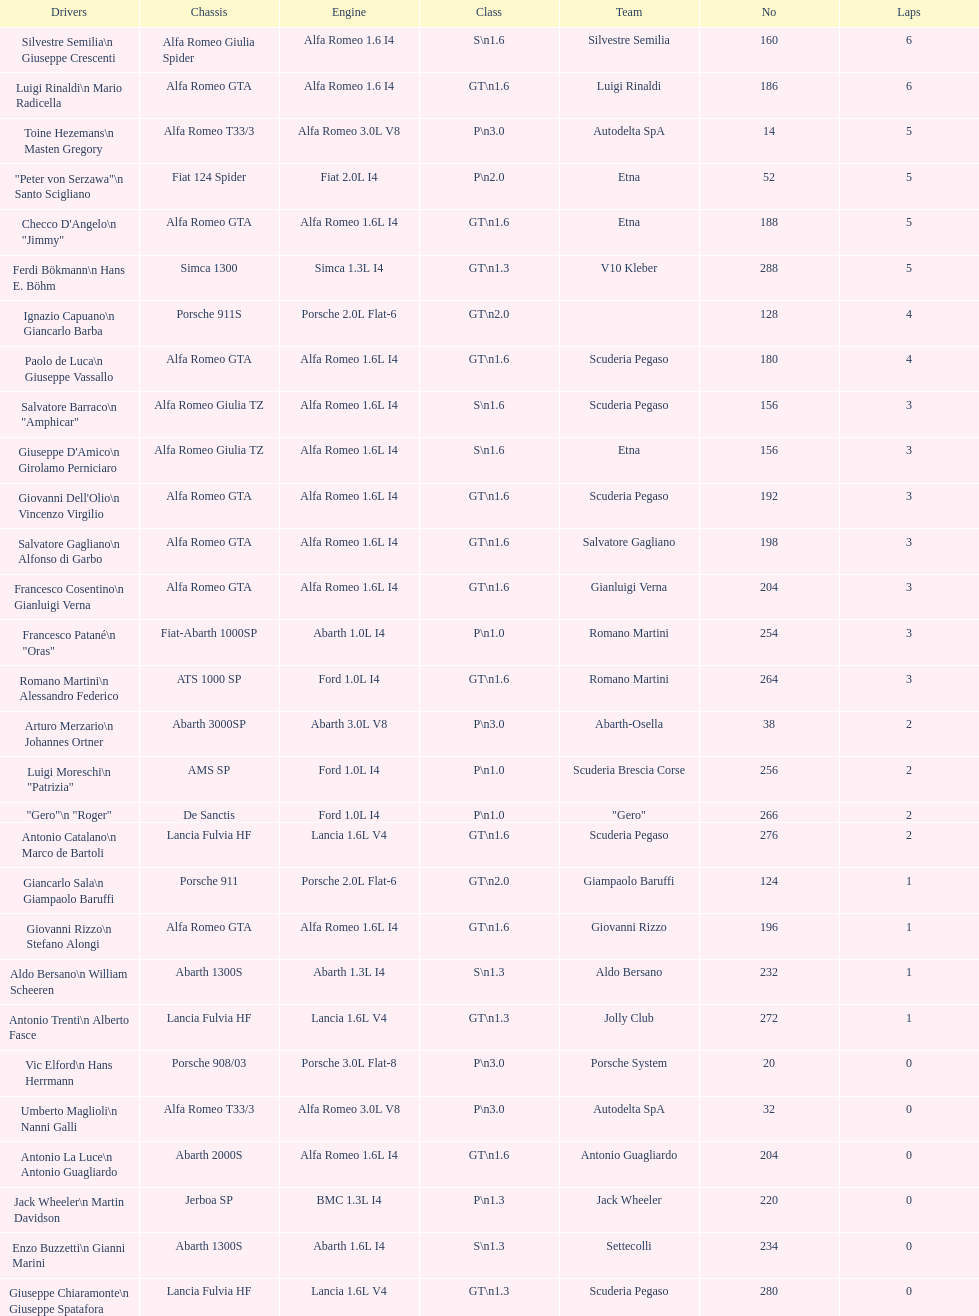How many drivers are from italy? 48. Would you be able to parse every entry in this table? {'header': ['Drivers', 'Chassis', 'Engine', 'Class', 'Team', 'No', 'Laps'], 'rows': [['Silvestre Semilia\\n Giuseppe Crescenti', 'Alfa Romeo Giulia Spider', 'Alfa Romeo 1.6 I4', 'S\\n1.6', 'Silvestre Semilia', '160', '6'], ['Luigi Rinaldi\\n Mario Radicella', 'Alfa Romeo GTA', 'Alfa Romeo 1.6 I4', 'GT\\n1.6', 'Luigi Rinaldi', '186', '6'], ['Toine Hezemans\\n Masten Gregory', 'Alfa Romeo T33/3', 'Alfa Romeo 3.0L V8', 'P\\n3.0', 'Autodelta SpA', '14', '5'], ['"Peter von Serzawa"\\n Santo Scigliano', 'Fiat 124 Spider', 'Fiat 2.0L I4', 'P\\n2.0', 'Etna', '52', '5'], ['Checco D\'Angelo\\n "Jimmy"', 'Alfa Romeo GTA', 'Alfa Romeo 1.6L I4', 'GT\\n1.6', 'Etna', '188', '5'], ['Ferdi Bökmann\\n Hans E. Böhm', 'Simca 1300', 'Simca 1.3L I4', 'GT\\n1.3', 'V10 Kleber', '288', '5'], ['Ignazio Capuano\\n Giancarlo Barba', 'Porsche 911S', 'Porsche 2.0L Flat-6', 'GT\\n2.0', '', '128', '4'], ['Paolo de Luca\\n Giuseppe Vassallo', 'Alfa Romeo GTA', 'Alfa Romeo 1.6L I4', 'GT\\n1.6', 'Scuderia Pegaso', '180', '4'], ['Salvatore Barraco\\n "Amphicar"', 'Alfa Romeo Giulia TZ', 'Alfa Romeo 1.6L I4', 'S\\n1.6', 'Scuderia Pegaso', '156', '3'], ["Giuseppe D'Amico\\n Girolamo Perniciaro", 'Alfa Romeo Giulia TZ', 'Alfa Romeo 1.6L I4', 'S\\n1.6', 'Etna', '156', '3'], ["Giovanni Dell'Olio\\n Vincenzo Virgilio", 'Alfa Romeo GTA', 'Alfa Romeo 1.6L I4', 'GT\\n1.6', 'Scuderia Pegaso', '192', '3'], ['Salvatore Gagliano\\n Alfonso di Garbo', 'Alfa Romeo GTA', 'Alfa Romeo 1.6L I4', 'GT\\n1.6', 'Salvatore Gagliano', '198', '3'], ['Francesco Cosentino\\n Gianluigi Verna', 'Alfa Romeo GTA', 'Alfa Romeo 1.6L I4', 'GT\\n1.6', 'Gianluigi Verna', '204', '3'], ['Francesco Patané\\n "Oras"', 'Fiat-Abarth 1000SP', 'Abarth 1.0L I4', 'P\\n1.0', 'Romano Martini', '254', '3'], ['Romano Martini\\n Alessandro Federico', 'ATS 1000 SP', 'Ford 1.0L I4', 'GT\\n1.6', 'Romano Martini', '264', '3'], ['Arturo Merzario\\n Johannes Ortner', 'Abarth 3000SP', 'Abarth 3.0L V8', 'P\\n3.0', 'Abarth-Osella', '38', '2'], ['Luigi Moreschi\\n "Patrizia"', 'AMS SP', 'Ford 1.0L I4', 'P\\n1.0', 'Scuderia Brescia Corse', '256', '2'], ['"Gero"\\n "Roger"', 'De Sanctis', 'Ford 1.0L I4', 'P\\n1.0', '"Gero"', '266', '2'], ['Antonio Catalano\\n Marco de Bartoli', 'Lancia Fulvia HF', 'Lancia 1.6L V4', 'GT\\n1.6', 'Scuderia Pegaso', '276', '2'], ['Giancarlo Sala\\n Giampaolo Baruffi', 'Porsche 911', 'Porsche 2.0L Flat-6', 'GT\\n2.0', 'Giampaolo Baruffi', '124', '1'], ['Giovanni Rizzo\\n Stefano Alongi', 'Alfa Romeo GTA', 'Alfa Romeo 1.6L I4', 'GT\\n1.6', 'Giovanni Rizzo', '196', '1'], ['Aldo Bersano\\n William Scheeren', 'Abarth 1300S', 'Abarth 1.3L I4', 'S\\n1.3', 'Aldo Bersano', '232', '1'], ['Antonio Trenti\\n Alberto Fasce', 'Lancia Fulvia HF', 'Lancia 1.6L V4', 'GT\\n1.3', 'Jolly Club', '272', '1'], ['Vic Elford\\n Hans Herrmann', 'Porsche 908/03', 'Porsche 3.0L Flat-8', 'P\\n3.0', 'Porsche System', '20', '0'], ['Umberto Maglioli\\n Nanni Galli', 'Alfa Romeo T33/3', 'Alfa Romeo 3.0L V8', 'P\\n3.0', 'Autodelta SpA', '32', '0'], ['Antonio La Luce\\n Antonio Guagliardo', 'Abarth 2000S', 'Alfa Romeo 1.6L I4', 'GT\\n1.6', 'Antonio Guagliardo', '204', '0'], ['Jack Wheeler\\n Martin Davidson', 'Jerboa SP', 'BMC 1.3L I4', 'P\\n1.3', 'Jack Wheeler', '220', '0'], ['Enzo Buzzetti\\n Gianni Marini', 'Abarth 1300S', 'Abarth 1.6L I4', 'S\\n1.3', 'Settecolli', '234', '0'], ['Giuseppe Chiaramonte\\n Giuseppe Spatafora', 'Lancia Fulvia HF', 'Lancia 1.6L V4', 'GT\\n1.3', 'Scuderia Pegaso', '280', '0']]} 